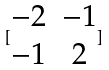<formula> <loc_0><loc_0><loc_500><loc_500>[ \begin{matrix} - 2 & - 1 \\ - 1 & 2 \end{matrix} ]</formula> 